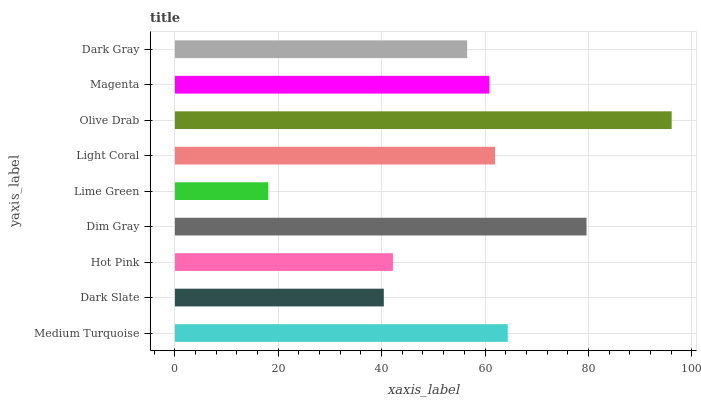Is Lime Green the minimum?
Answer yes or no. Yes. Is Olive Drab the maximum?
Answer yes or no. Yes. Is Dark Slate the minimum?
Answer yes or no. No. Is Dark Slate the maximum?
Answer yes or no. No. Is Medium Turquoise greater than Dark Slate?
Answer yes or no. Yes. Is Dark Slate less than Medium Turquoise?
Answer yes or no. Yes. Is Dark Slate greater than Medium Turquoise?
Answer yes or no. No. Is Medium Turquoise less than Dark Slate?
Answer yes or no. No. Is Magenta the high median?
Answer yes or no. Yes. Is Magenta the low median?
Answer yes or no. Yes. Is Dark Gray the high median?
Answer yes or no. No. Is Lime Green the low median?
Answer yes or no. No. 